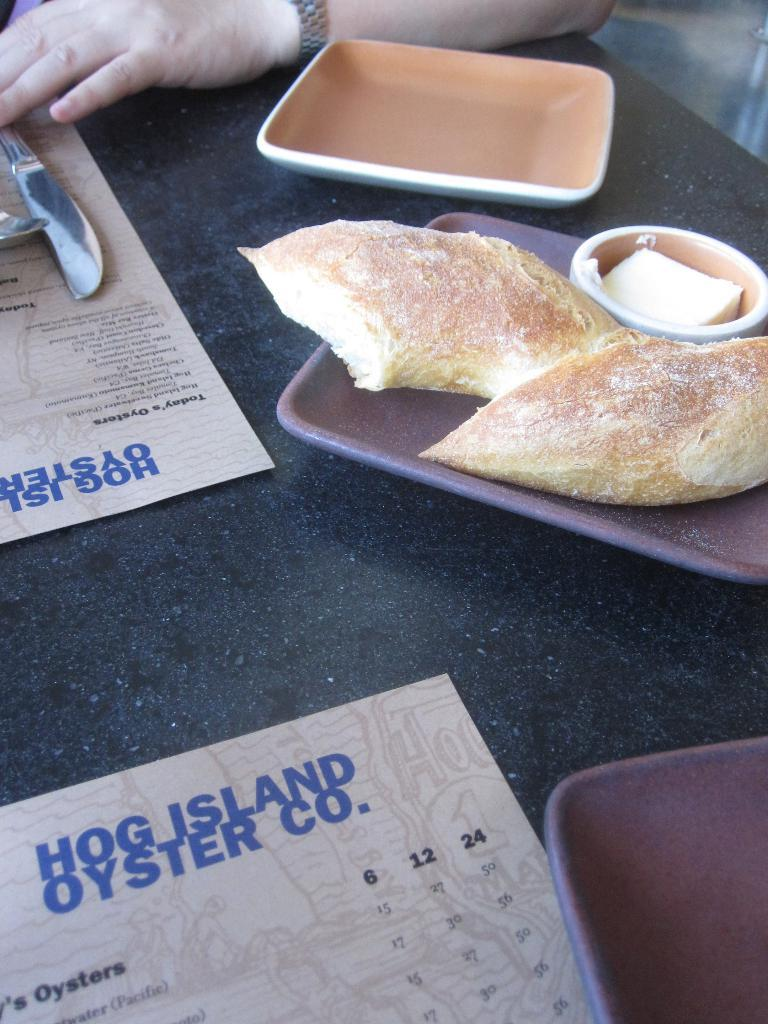What is on the plate in the image? There is food in a plate in the image. What else can be seen near the plate? Papers are present beside the plate. What utensils are visible in the image? A spoon and a knife are present in the image. How many plates are on the table in the image? There are additional plates on the table. Who is in front of the table in the image? There is a person in front of the table in the image. What type of cake is being prepared on the pan in the image? There is no pan or cake present in the image. What type of business is being conducted at the table in the image? The image does not depict any business-related activities; it shows a person in front of a table with food and utensils. 